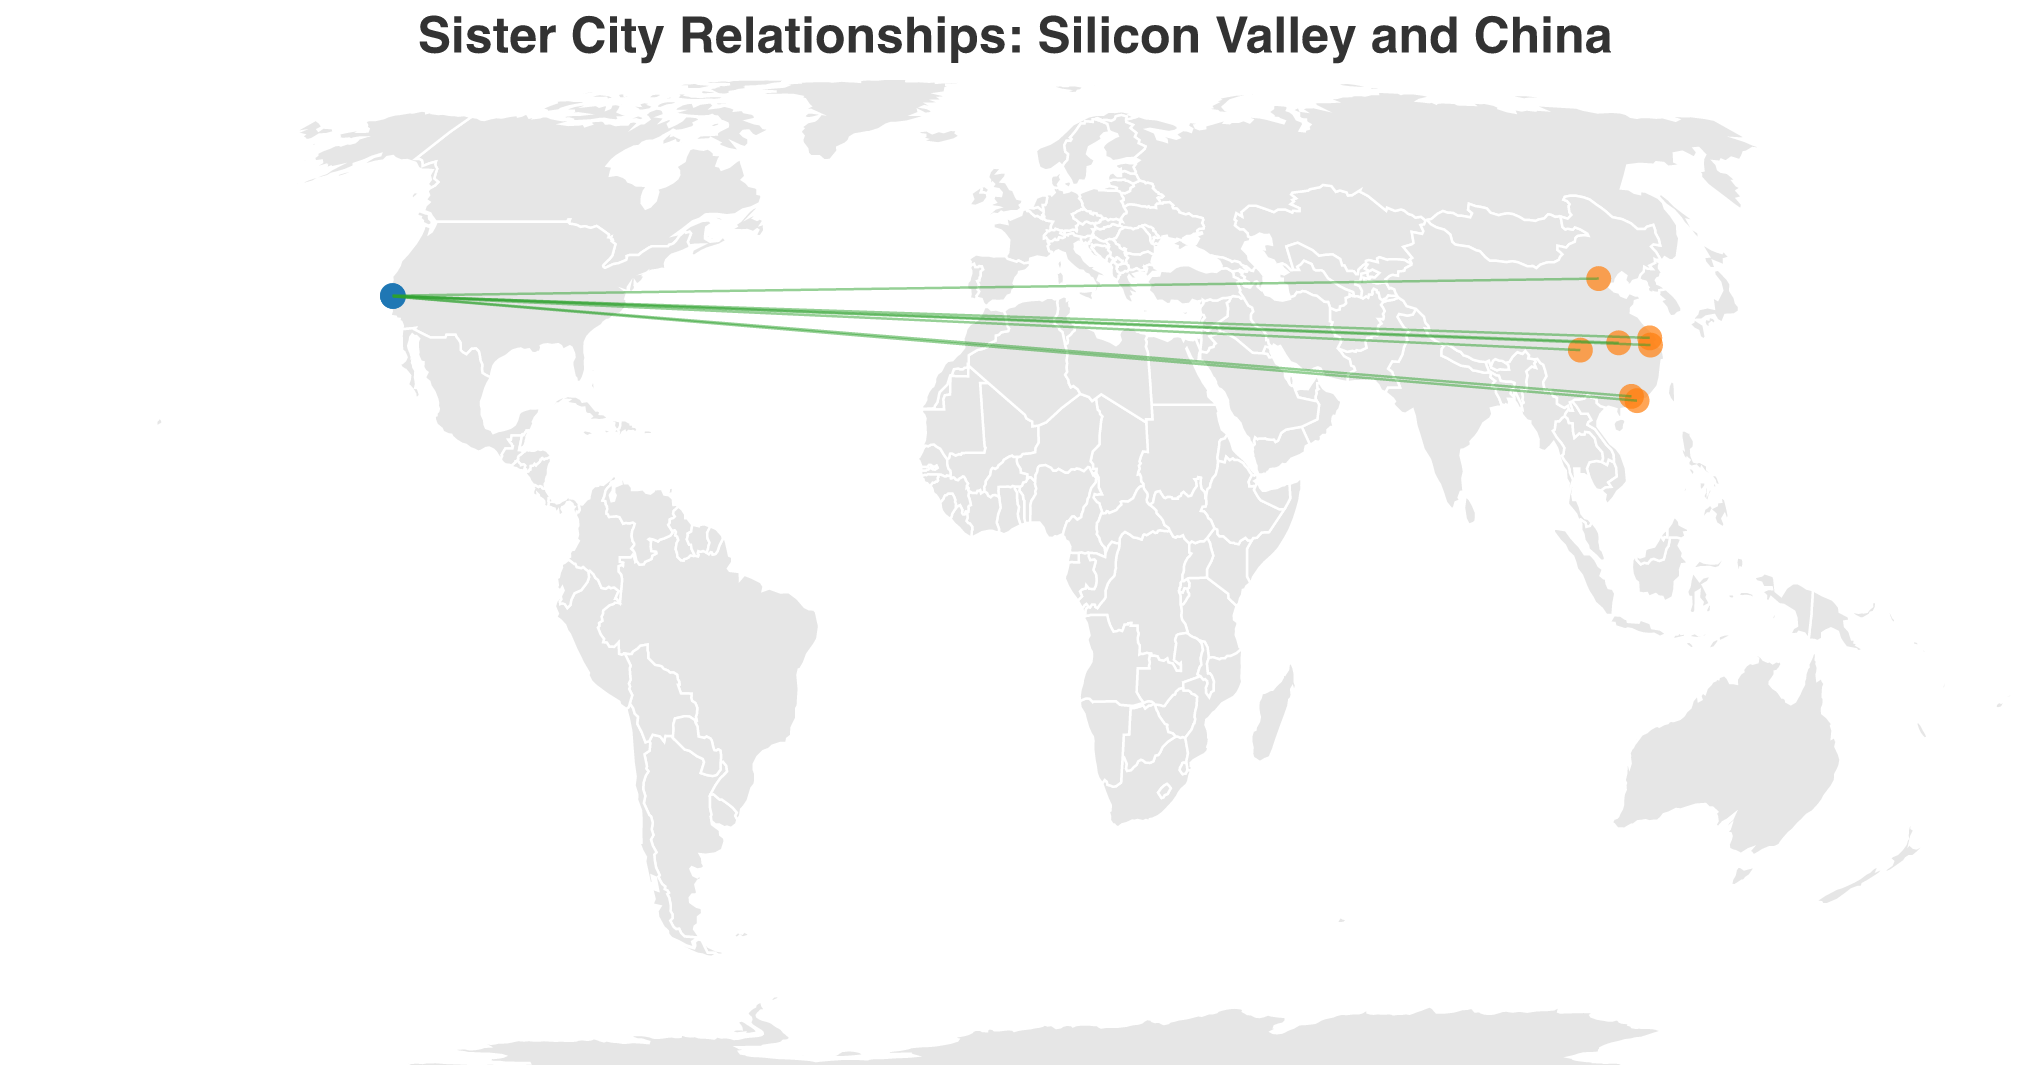Which city is paired with Hangzhou? By looking at the points connected by lines, we identify that the line connecting to Hangzhou originates from Mountain View in Silicon Valley.
Answer: Mountain View What is the title of the plot? The title is clearly displayed at the top of the figure.
Answer: Sister City Relationships: Silicon Valley and China How many Silicon Valley cities have sister city relationships represented in the plot? Each blue circle represents a Silicon Valley city and counting these circles gives the total number. There are 7 blue circles.
Answer: 7 Which Chinese city is connected to Cupertino? By following the line originating from Cupertino, we can see that it connects to Shenzhen.
Answer: Shenzhen Among the Silicon Valley cities, which one is the northernmost? The northernmost city can be identified by looking at the latitude (vertical position) of the blue circles. Menlo Park has the highest latitude.
Answer: Menlo Park Which Chinese city is the easternmost? The easternmost city can be determined by looking at the longitude (horizontal position) of the orange circles. Tsinghua Science Park is the furthest to the right.
Answer: Tsinghua Science Park What is the average latitude of the Chinese cities? The latitudes of Chinese cities are: 23.1291, 40.0000, 22.5431, 30.2741, 31.2984, 29.5630, and 30.5928. Adding these values together and dividing by 7 gives the average. (23.1291 + 40.0000 + 22.5431 + 30.2741 + 31.2984 + 29.5630 + 30.5928) / 7 ≈ 29.057
Answer: ≈ 29.057 Which Chinese city is directly west of Santa Clara? By looking at the orange circles to the left of Santa Clara's corresponding circle, we see that Chongqing is almost directly west.
Answer: Chongqing Do any Silicon Valley cities pair with Chinese cities that have similar latitudes? We can compare the latitudes of each Silicon Valley city with their Chinese partner. Cupertino (37.3230) and Palo Alto (37.4419) both pair with Shenzhen (22.5431) and Tsinghua Science Park (40.0000) respectively, and their latitudes differ significantly. Only Sunnyvale (37.3688) and Suzhou (31.2984) have somewhat closer latitudes but not similar enough to be considered very close.
Answer: No Which pair of cities have the longest line between them? The longest line can be estimated by looking at the visual distance between the connected pairs on the plot. San Jose (Silicon Valley) and Guangzhou (China) appear to be the furthest apart, stretching across the entire plot.
Answer: San Jose and Guangzhou 